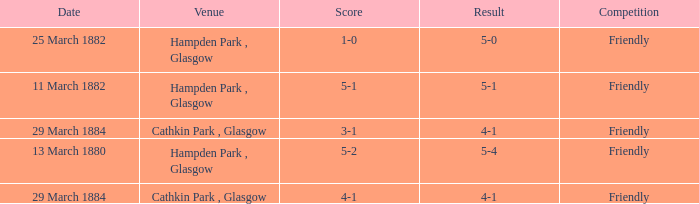Which item has a score of 5-1? 5-1. 